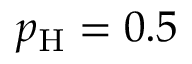<formula> <loc_0><loc_0><loc_500><loc_500>p _ { H } = 0 . 5</formula> 